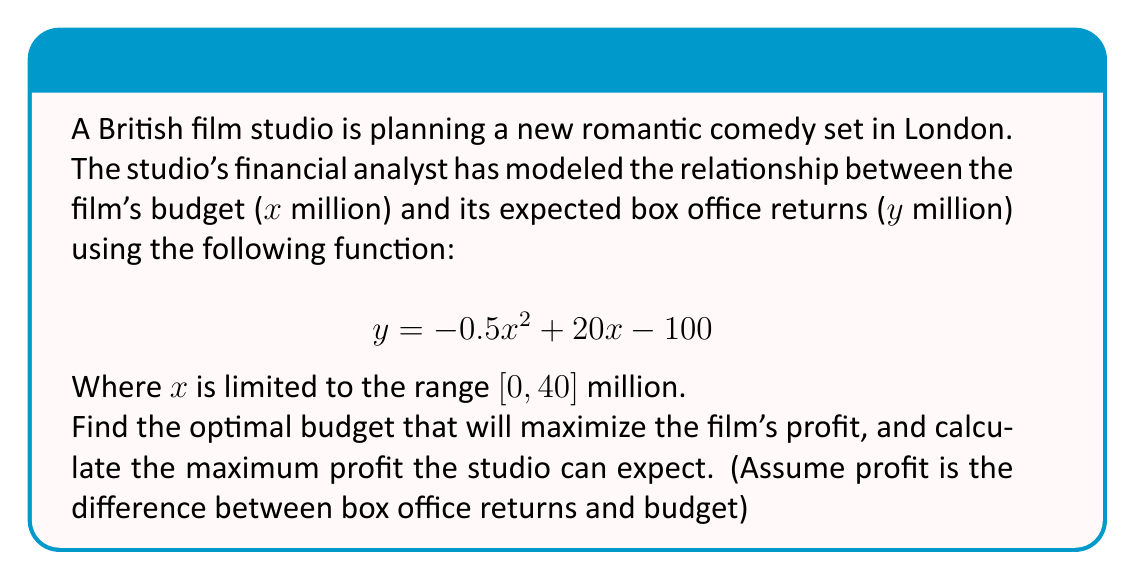Can you answer this question? Let's approach this step-by-step:

1) First, we need to define the profit function. Profit is the difference between returns and budget:
   $$P(x) = y - x = (-0.5x^2 + 20x - 100) - x = -0.5x^2 + 19x - 100$$

2) To find the maximum profit, we need to find where the derivative of $P(x)$ equals zero:
   $$\frac{d}{dx}P(x) = -x + 19$$
   
3) Set this equal to zero and solve:
   $$-x + 19 = 0$$
   $$x = 19$$

4) To confirm this is a maximum (not a minimum), we can check the second derivative:
   $$\frac{d^2}{dx^2}P(x) = -1$$
   Since this is negative, we confirm $x = 19$ gives a maximum.

5) Now, let's calculate the maximum profit by plugging $x = 19$ into our profit function:
   $$P(19) = -0.5(19)^2 + 19(19) - 100$$
   $$= -180.5 + 361 - 100$$
   $$= 80.5$$

6) We should also check if this budget is within the given range $[0, 40]$. It is, so this is our final answer.
Answer: Optimal budget: $19 million. Maximum profit: $80.5 million. 